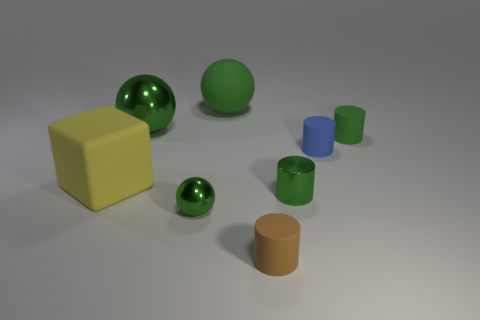Subtract all tiny blue cylinders. How many cylinders are left? 3 Subtract all blue cylinders. How many cylinders are left? 3 Subtract all spheres. How many objects are left? 5 Add 4 small brown matte objects. How many small brown matte objects exist? 5 Add 2 big objects. How many objects exist? 10 Subtract 0 gray balls. How many objects are left? 8 Subtract 1 cubes. How many cubes are left? 0 Subtract all purple spheres. Subtract all gray cubes. How many spheres are left? 3 Subtract all cyan balls. How many purple cubes are left? 0 Subtract all gray shiny blocks. Subtract all tiny metallic spheres. How many objects are left? 7 